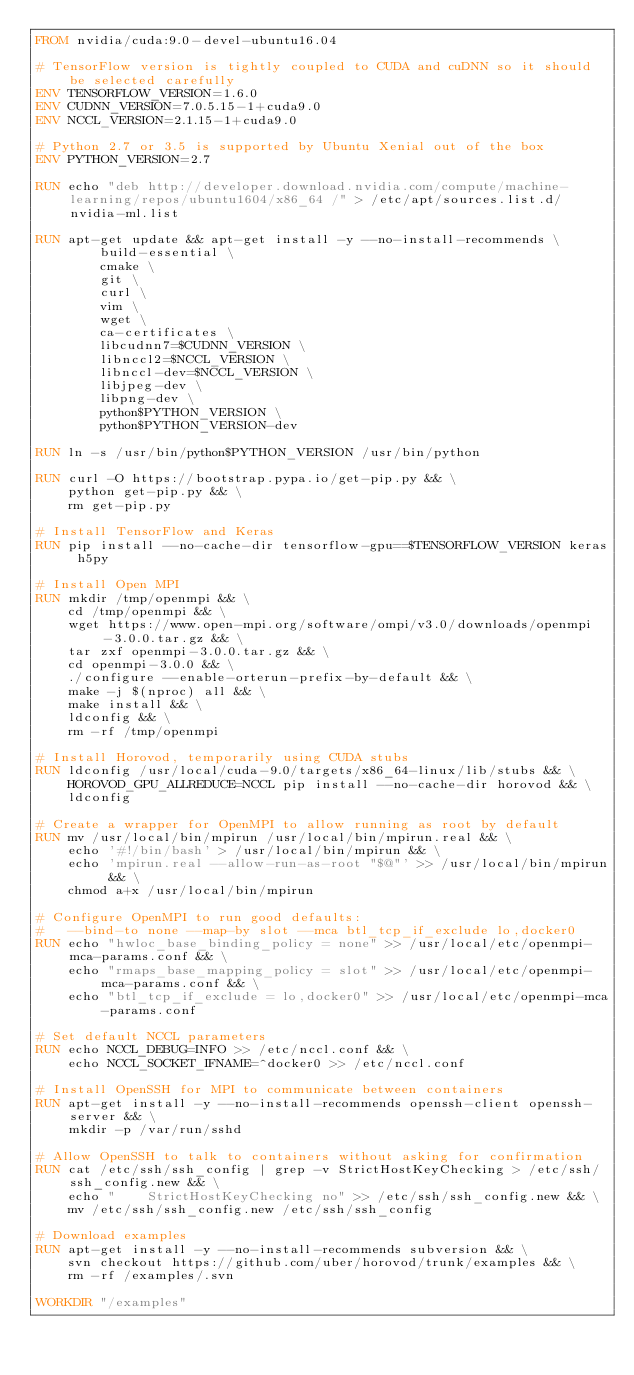Convert code to text. <code><loc_0><loc_0><loc_500><loc_500><_Dockerfile_>FROM nvidia/cuda:9.0-devel-ubuntu16.04

# TensorFlow version is tightly coupled to CUDA and cuDNN so it should be selected carefully
ENV TENSORFLOW_VERSION=1.6.0
ENV CUDNN_VERSION=7.0.5.15-1+cuda9.0
ENV NCCL_VERSION=2.1.15-1+cuda9.0

# Python 2.7 or 3.5 is supported by Ubuntu Xenial out of the box
ENV PYTHON_VERSION=2.7

RUN echo "deb http://developer.download.nvidia.com/compute/machine-learning/repos/ubuntu1604/x86_64 /" > /etc/apt/sources.list.d/nvidia-ml.list

RUN apt-get update && apt-get install -y --no-install-recommends \
        build-essential \
        cmake \
        git \
        curl \
        vim \
        wget \
        ca-certificates \
        libcudnn7=$CUDNN_VERSION \
        libnccl2=$NCCL_VERSION \
        libnccl-dev=$NCCL_VERSION \
        libjpeg-dev \
        libpng-dev \
        python$PYTHON_VERSION \
        python$PYTHON_VERSION-dev

RUN ln -s /usr/bin/python$PYTHON_VERSION /usr/bin/python

RUN curl -O https://bootstrap.pypa.io/get-pip.py && \
    python get-pip.py && \
    rm get-pip.py

# Install TensorFlow and Keras
RUN pip install --no-cache-dir tensorflow-gpu==$TENSORFLOW_VERSION keras h5py

# Install Open MPI
RUN mkdir /tmp/openmpi && \
    cd /tmp/openmpi && \
    wget https://www.open-mpi.org/software/ompi/v3.0/downloads/openmpi-3.0.0.tar.gz && \
    tar zxf openmpi-3.0.0.tar.gz && \
    cd openmpi-3.0.0 && \
    ./configure --enable-orterun-prefix-by-default && \
    make -j $(nproc) all && \
    make install && \
    ldconfig && \
    rm -rf /tmp/openmpi

# Install Horovod, temporarily using CUDA stubs
RUN ldconfig /usr/local/cuda-9.0/targets/x86_64-linux/lib/stubs && \
    HOROVOD_GPU_ALLREDUCE=NCCL pip install --no-cache-dir horovod && \
    ldconfig

# Create a wrapper for OpenMPI to allow running as root by default
RUN mv /usr/local/bin/mpirun /usr/local/bin/mpirun.real && \
    echo '#!/bin/bash' > /usr/local/bin/mpirun && \
    echo 'mpirun.real --allow-run-as-root "$@"' >> /usr/local/bin/mpirun && \
    chmod a+x /usr/local/bin/mpirun

# Configure OpenMPI to run good defaults:
#   --bind-to none --map-by slot --mca btl_tcp_if_exclude lo,docker0
RUN echo "hwloc_base_binding_policy = none" >> /usr/local/etc/openmpi-mca-params.conf && \
    echo "rmaps_base_mapping_policy = slot" >> /usr/local/etc/openmpi-mca-params.conf && \
    echo "btl_tcp_if_exclude = lo,docker0" >> /usr/local/etc/openmpi-mca-params.conf

# Set default NCCL parameters
RUN echo NCCL_DEBUG=INFO >> /etc/nccl.conf && \
    echo NCCL_SOCKET_IFNAME=^docker0 >> /etc/nccl.conf

# Install OpenSSH for MPI to communicate between containers
RUN apt-get install -y --no-install-recommends openssh-client openssh-server && \
    mkdir -p /var/run/sshd

# Allow OpenSSH to talk to containers without asking for confirmation
RUN cat /etc/ssh/ssh_config | grep -v StrictHostKeyChecking > /etc/ssh/ssh_config.new && \
    echo "    StrictHostKeyChecking no" >> /etc/ssh/ssh_config.new && \
    mv /etc/ssh/ssh_config.new /etc/ssh/ssh_config

# Download examples
RUN apt-get install -y --no-install-recommends subversion && \
    svn checkout https://github.com/uber/horovod/trunk/examples && \
    rm -rf /examples/.svn

WORKDIR "/examples"
</code> 